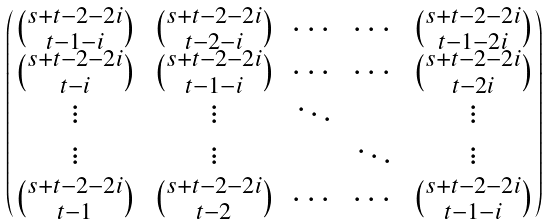Convert formula to latex. <formula><loc_0><loc_0><loc_500><loc_500>\begin{pmatrix} \binom { s + t - 2 - 2 i } { t - 1 - i } & \binom { s + t - 2 - 2 i } { t - 2 - i } & \cdots & \cdots & \binom { s + t - 2 - 2 i } { t - 1 - 2 i } \\ \binom { s + t - 2 - 2 i } { t - i } & \binom { s + t - 2 - 2 i } { t - 1 - i } & \cdots & \cdots & \binom { s + t - 2 - 2 i } { t - 2 i } \\ \vdots & \vdots & \ddots & & \vdots \\ \vdots & \vdots & & \ddots & \vdots \\ \binom { s + t - 2 - 2 i } { t - 1 } & \binom { s + t - 2 - 2 i } { t - 2 } & \cdots & \cdots & \binom { s + t - 2 - 2 i } { t - 1 - i } \\ \end{pmatrix}</formula> 